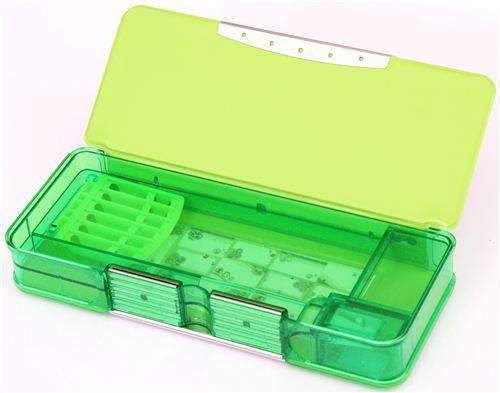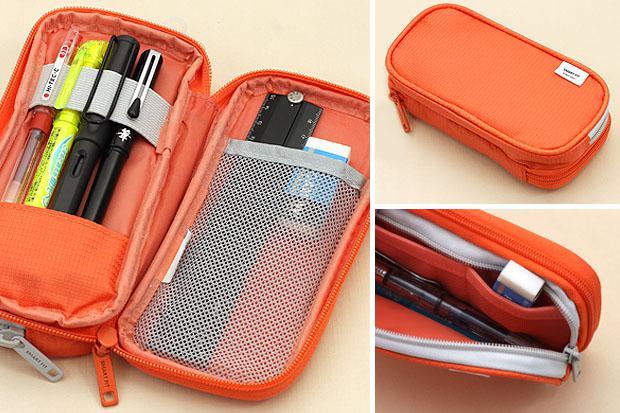The first image is the image on the left, the second image is the image on the right. Given the left and right images, does the statement "The image on the left shows a single pencil case that is closed." hold true? Answer yes or no. No. 